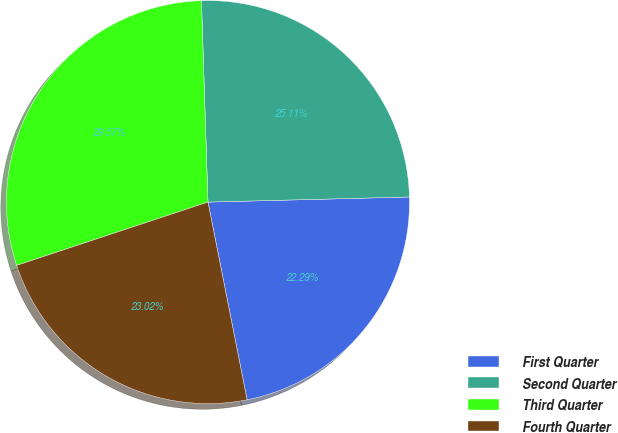Convert chart. <chart><loc_0><loc_0><loc_500><loc_500><pie_chart><fcel>First Quarter<fcel>Second Quarter<fcel>Third Quarter<fcel>Fourth Quarter<nl><fcel>22.29%<fcel>25.11%<fcel>29.57%<fcel>23.02%<nl></chart> 